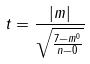<formula> <loc_0><loc_0><loc_500><loc_500>t = \frac { | m | } { \sqrt { \frac { 7 - m ^ { 0 } } { n - 0 } } }</formula> 